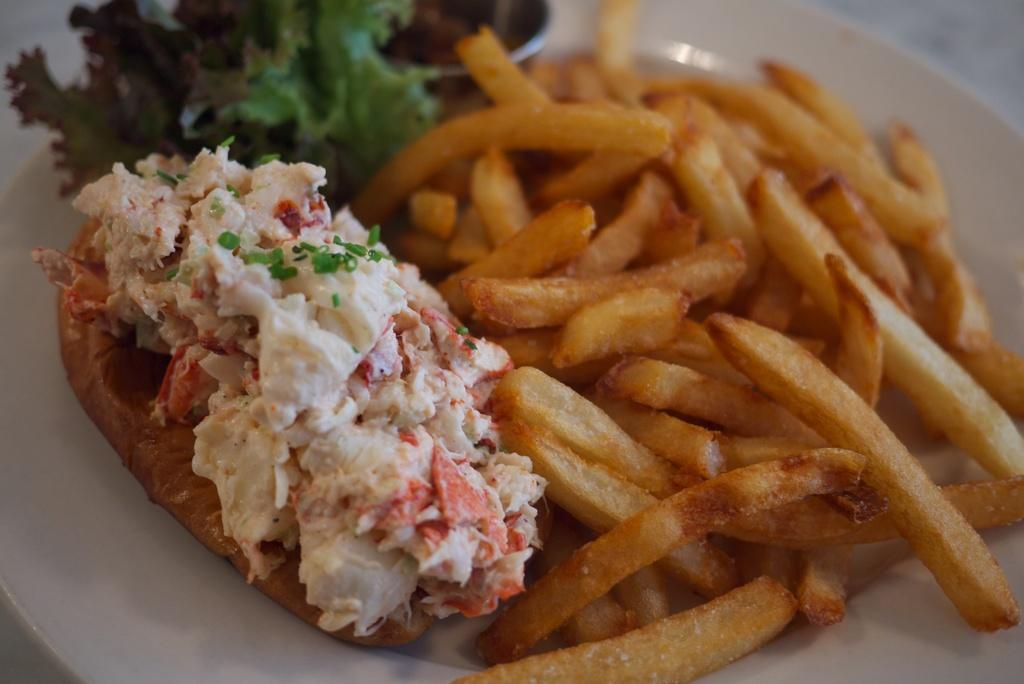What is on the plate that is visible in the image? The plate contains fries. What type of food is on the plate? There is food on the plate, specifically fries. What type of water can be seen flowing through the fries in the image? There is no water present in the image; it is a plate of fries. How are the fries distributed on the plate in the image? The distribution of the fries on the plate cannot be determined from the image alone, as it only shows the plate and fries without any context or perspective. 